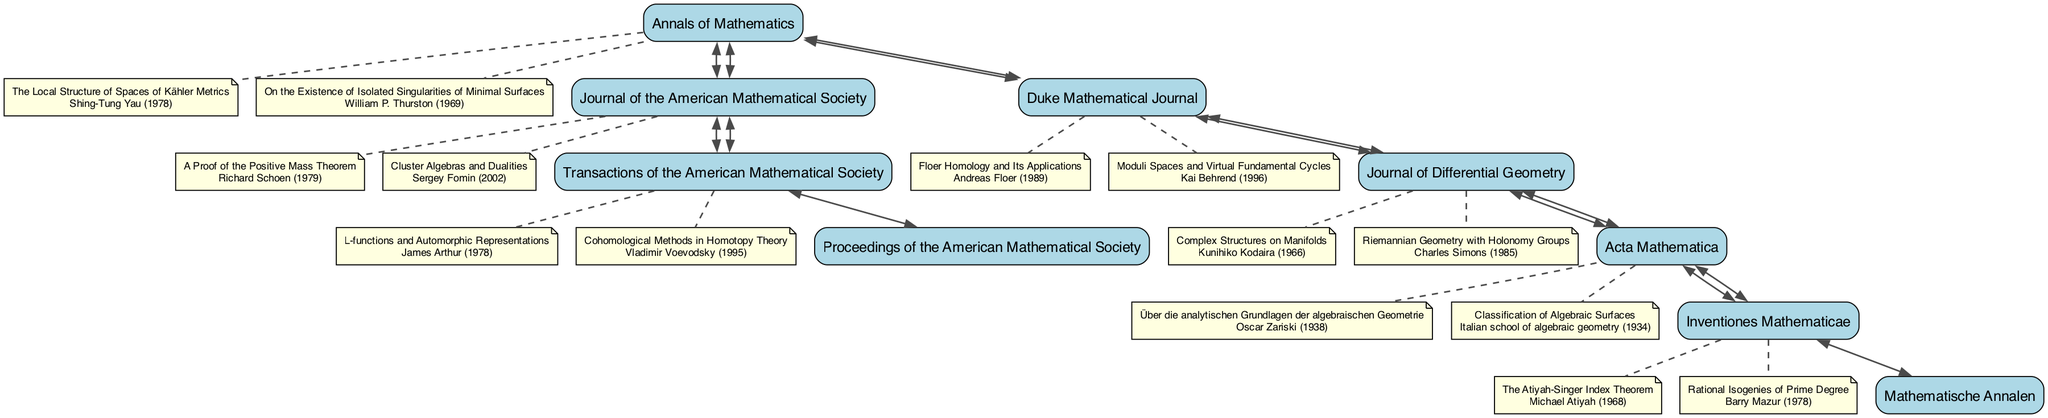What is the total number of journals displayed in the diagram? The diagram lists a total of six journals: Annals of Mathematics, Journal of the American Mathematical Society, Duke Mathematical Journal, Transactions of the American Mathematical Society, Journal of Differential Geometry, Acta Mathematica, and Inventiones Mathematicae.
Answer: 6 Which journal is connected to both Annals of Mathematics and Journal of Differential Geometry? The Duke Mathematical Journal is directly connected to Annals of Mathematics and also to Journal of Differential Geometry, as indicated by the arrows in the diagram.
Answer: Duke Mathematical Journal Who authored the paper titled "L-functions and Automorphic Representations"? The diagram shows that the paper "L-functions and Automorphic Representations" was authored by James Arthur, listed with the Transactions of the American Mathematical Society.
Answer: James Arthur Which significant paper published in Acta Mathematica is associated with the Italian school of algebraic geometry? The paper titled "Classification of Algebraic Surfaces" is associated with the Italian school of algebraic geometry and is noted as a significant paper within the Acta Mathematica node of the diagram.
Answer: Classification of Algebraic Surfaces How many significant papers are listed under the Journal of the American Mathematical Society? There are two significant papers listed under the Journal of the American Mathematical Society: "A Proof of the Positive Mass Theorem" and "Cluster Algebras and Dualities".
Answer: 2 Which journal shows connections to both Annals of Mathematics and Transactions of the American Mathematical Society? The Journal of the American Mathematical Society connects with both Annals of Mathematics and Transactions of the American Mathematical Society, as indicated by direct edges from the diagram.
Answer: Journal of the American Mathematical Society What year was the paper "The Local Structure of Spaces of Kähler Metrics" published? The diagram indicates that "The Local Structure of Spaces of Kähler Metrics" was published in 1978, denoting its significance under the Annals of Mathematics journal.
Answer: 1978 How many connections does the Transactions of the American Mathematical Society have? The Transactions of the American Mathematical Society is connected to two other journals: the Journal of the American Mathematical Society and Proceedings of the American Mathematical Society. Therefore, it has a total of two connections.
Answer: 2 Which journal is associated with the paper "Rational Isogenies of Prime Degree"? The paper "Rational Isogenies of Prime Degree" is associated with the Inventiones Mathematicae, as shown in the significant papers section of that journal in the diagram.
Answer: Inventiones Mathematicae 